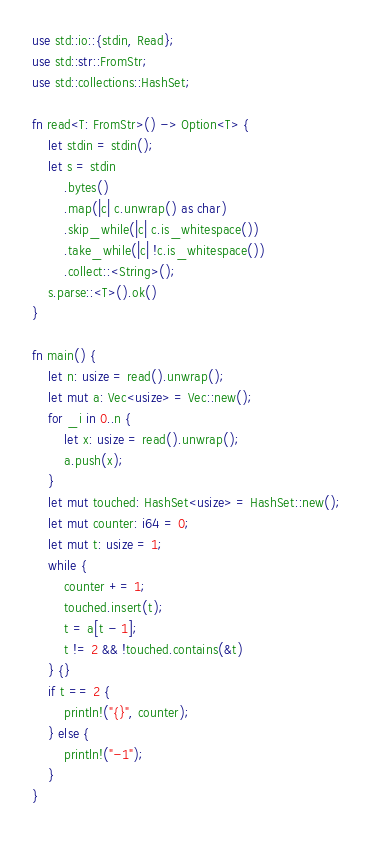Convert code to text. <code><loc_0><loc_0><loc_500><loc_500><_Rust_>use std::io::{stdin, Read};
use std::str::FromStr;
use std::collections::HashSet;

fn read<T: FromStr>() -> Option<T> {
    let stdin = stdin();
    let s = stdin
        .bytes()
        .map(|c| c.unwrap() as char)
        .skip_while(|c| c.is_whitespace())
        .take_while(|c| !c.is_whitespace())
        .collect::<String>();
    s.parse::<T>().ok()
}
 
fn main() {
    let n: usize = read().unwrap();
    let mut a: Vec<usize> = Vec::new();
    for _i in 0..n {
        let x: usize = read().unwrap();
        a.push(x);
    }
    let mut touched: HashSet<usize> = HashSet::new();
    let mut counter: i64 = 0;
    let mut t: usize = 1;
    while {
        counter += 1;
        touched.insert(t);
        t = a[t - 1];
        t != 2 && !touched.contains(&t)
    } {}
    if t == 2 {
        println!("{}", counter);
    } else {
        println!("-1");
    }
}
</code> 